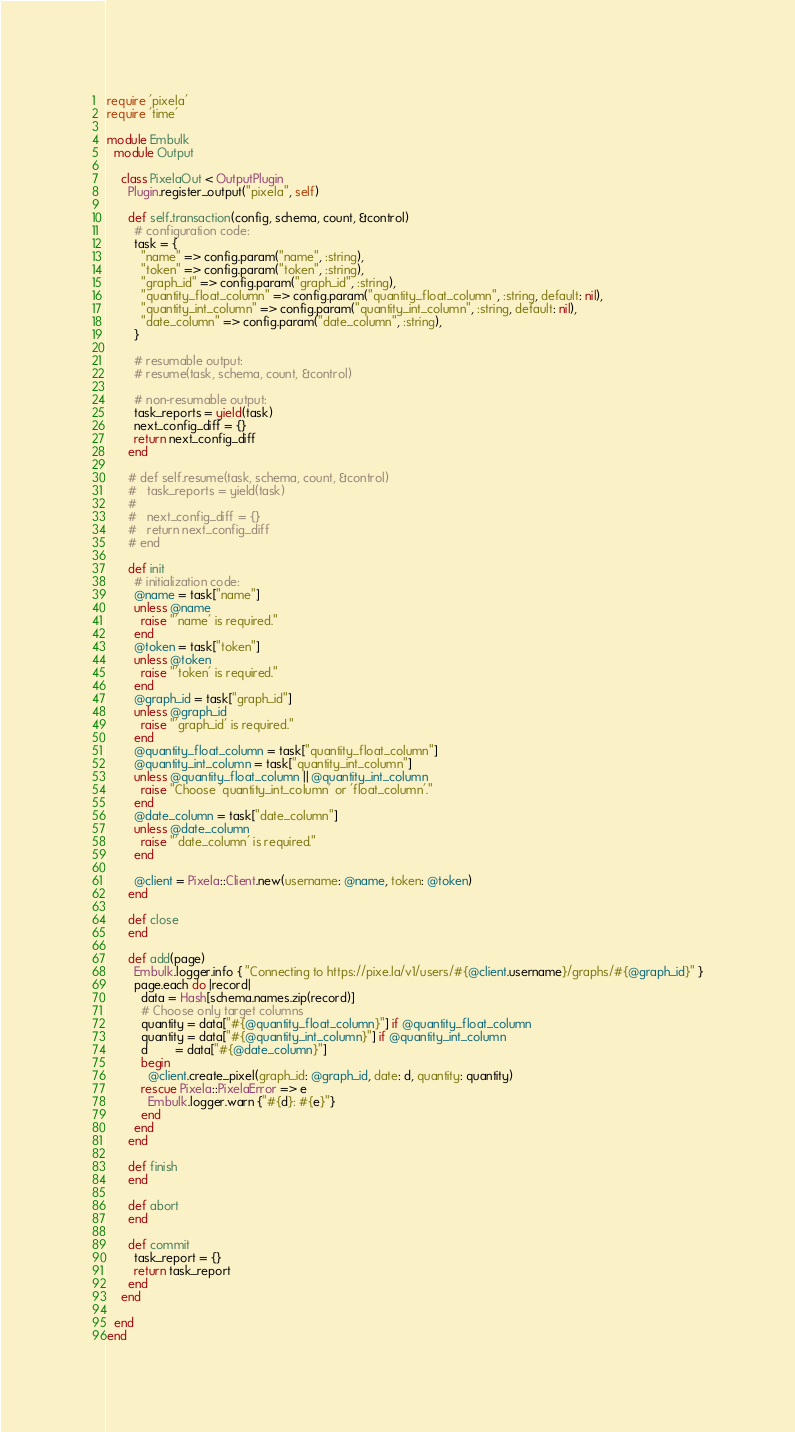<code> <loc_0><loc_0><loc_500><loc_500><_Ruby_>require 'pixela'
require 'time'

module Embulk
  module Output

    class PixelaOut < OutputPlugin
      Plugin.register_output("pixela", self)

      def self.transaction(config, schema, count, &control)
        # configuration code:
        task = {
          "name" => config.param("name", :string),
          "token" => config.param("token", :string),
          "graph_id" => config.param("graph_id", :string),
          "quantity_float_column" => config.param("quantity_float_column", :string, default: nil),
          "quantity_int_column" => config.param("quantity_int_column", :string, default: nil),
          "date_column" => config.param("date_column", :string),
        }

        # resumable output:
        # resume(task, schema, count, &control)

        # non-resumable output:
        task_reports = yield(task)
        next_config_diff = {}
        return next_config_diff
      end

      # def self.resume(task, schema, count, &control)
      #   task_reports = yield(task)
      #
      #   next_config_diff = {}
      #   return next_config_diff
      # end

      def init
        # initialization code:
        @name = task["name"]
        unless @name
          raise "'name' is required."
        end
        @token = task["token"]
        unless @token
          raise "'token' is required."
        end
        @graph_id = task["graph_id"]
        unless @graph_id
          raise "'graph_id' is required."
        end
        @quantity_float_column = task["quantity_float_column"]
        @quantity_int_column = task["quantity_int_column"]
        unless @quantity_float_column || @quantity_int_column
          raise "Choose 'quantity_int_column' or 'float_column'."
        end
        @date_column = task["date_column"]
        unless @date_column
          raise "'date_column' is required."
        end

        @client = Pixela::Client.new(username: @name, token: @token)
      end

      def close
      end

      def add(page)
        Embulk.logger.info { "Connecting to https://pixe.la/v1/users/#{@client.username}/graphs/#{@graph_id}" }
        page.each do |record|
          data = Hash[schema.names.zip(record)]
          # Choose only target columns
          quantity = data["#{@quantity_float_column}"] if @quantity_float_column
          quantity = data["#{@quantity_int_column}"] if @quantity_int_column
          d        = data["#{@date_column}"]
          begin
            @client.create_pixel(graph_id: @graph_id, date: d, quantity: quantity)
          rescue Pixela::PixelaError => e
            Embulk.logger.warn {"#{d}: #{e}"}              
          end
        end
      end

      def finish
      end

      def abort
      end

      def commit
        task_report = {}
        return task_report
      end
    end

  end
end
</code> 